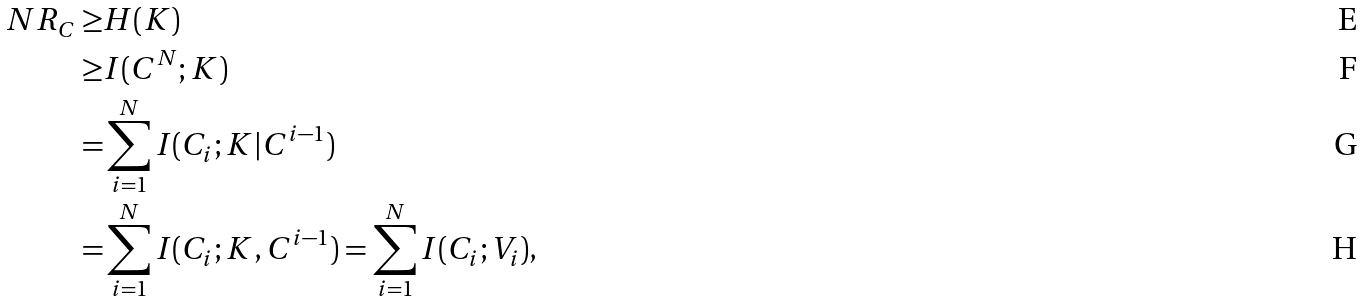Convert formula to latex. <formula><loc_0><loc_0><loc_500><loc_500>N R _ { C } \geq & H ( K ) \\ \geq & I ( C ^ { N } ; K ) \\ = & \sum _ { i = 1 } ^ { N } I ( C _ { i } ; K | C ^ { i - 1 } ) \\ = & \sum _ { i = 1 } ^ { N } I ( C _ { i } ; K , C ^ { i - 1 } ) = \sum _ { i = 1 } ^ { N } I ( C _ { i } ; V _ { i } ) ,</formula> 